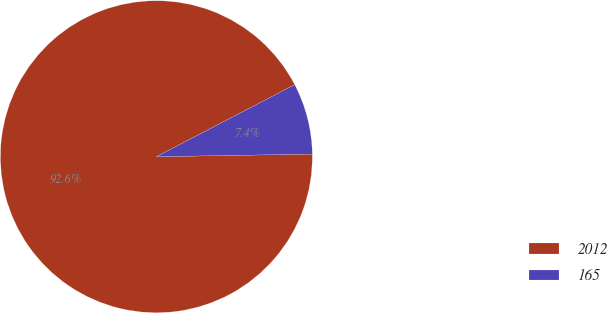<chart> <loc_0><loc_0><loc_500><loc_500><pie_chart><fcel>2012<fcel>165<nl><fcel>92.63%<fcel>7.37%<nl></chart> 